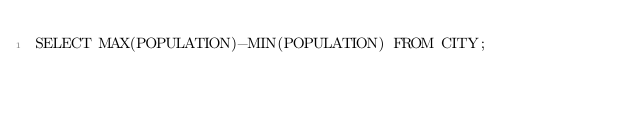Convert code to text. <code><loc_0><loc_0><loc_500><loc_500><_SQL_>SELECT MAX(POPULATION)-MIN(POPULATION) FROM CITY;</code> 